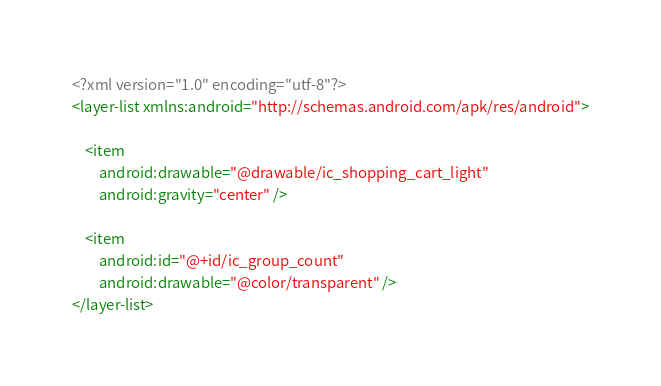Convert code to text. <code><loc_0><loc_0><loc_500><loc_500><_XML_><?xml version="1.0" encoding="utf-8"?>
<layer-list xmlns:android="http://schemas.android.com/apk/res/android">

    <item
        android:drawable="@drawable/ic_shopping_cart_light"
        android:gravity="center" />

    <item
        android:id="@+id/ic_group_count"
        android:drawable="@color/transparent" />
</layer-list></code> 